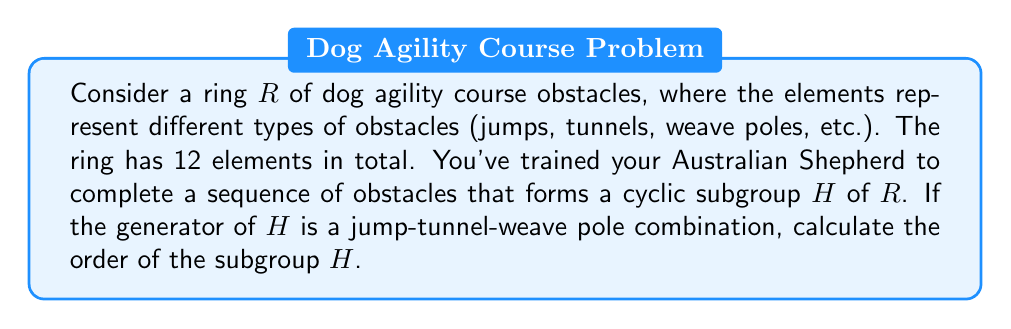Help me with this question. To solve this problem, we need to understand a few key concepts:

1. In ring theory, a cyclic subgroup is generated by a single element.
2. The order of a cyclic subgroup is the smallest positive integer $n$ such that $a^n = e$, where $a$ is the generator and $e$ is the identity element.
3. In this context, the "addition" operation in the ring could represent concatenation of obstacle sequences.

Let's approach this step-by-step:

1. The ring $R$ has 12 elements, which means its order is $|R| = 12$.

2. The generator of the cyclic subgroup $H$ is a jump-tunnel-weave pole combination. Let's call this generator $a$.

3. By Lagrange's theorem, we know that the order of a subgroup must divide the order of the group. So, the possible orders for $H$ are the divisors of 12: 1, 2, 3, 4, 6, and 12.

4. To find the actual order of $H$, we need to consider how many times we need to repeat the generator $a$ to get back to the identity element (which in this case could be considered as completing a full course).

5. Let's examine the possibilities:
   - $a^1$: jump-tunnel-weave pole (not a complete course)
   - $a^2$: jump-tunnel-weave pole-jump-tunnel-weave pole (not a complete course)
   - $a^3$: jump-tunnel-weave pole-jump-tunnel-weave pole-jump-tunnel-weave pole (could be a complete course)

6. $a^3$ forms a complete sequence that brings us back to the starting point, effectively acting as the identity element in this context.

Therefore, the order of the cyclic subgroup $H$ is 3.
Answer: The order of the cyclic subgroup $H$ is 3. 